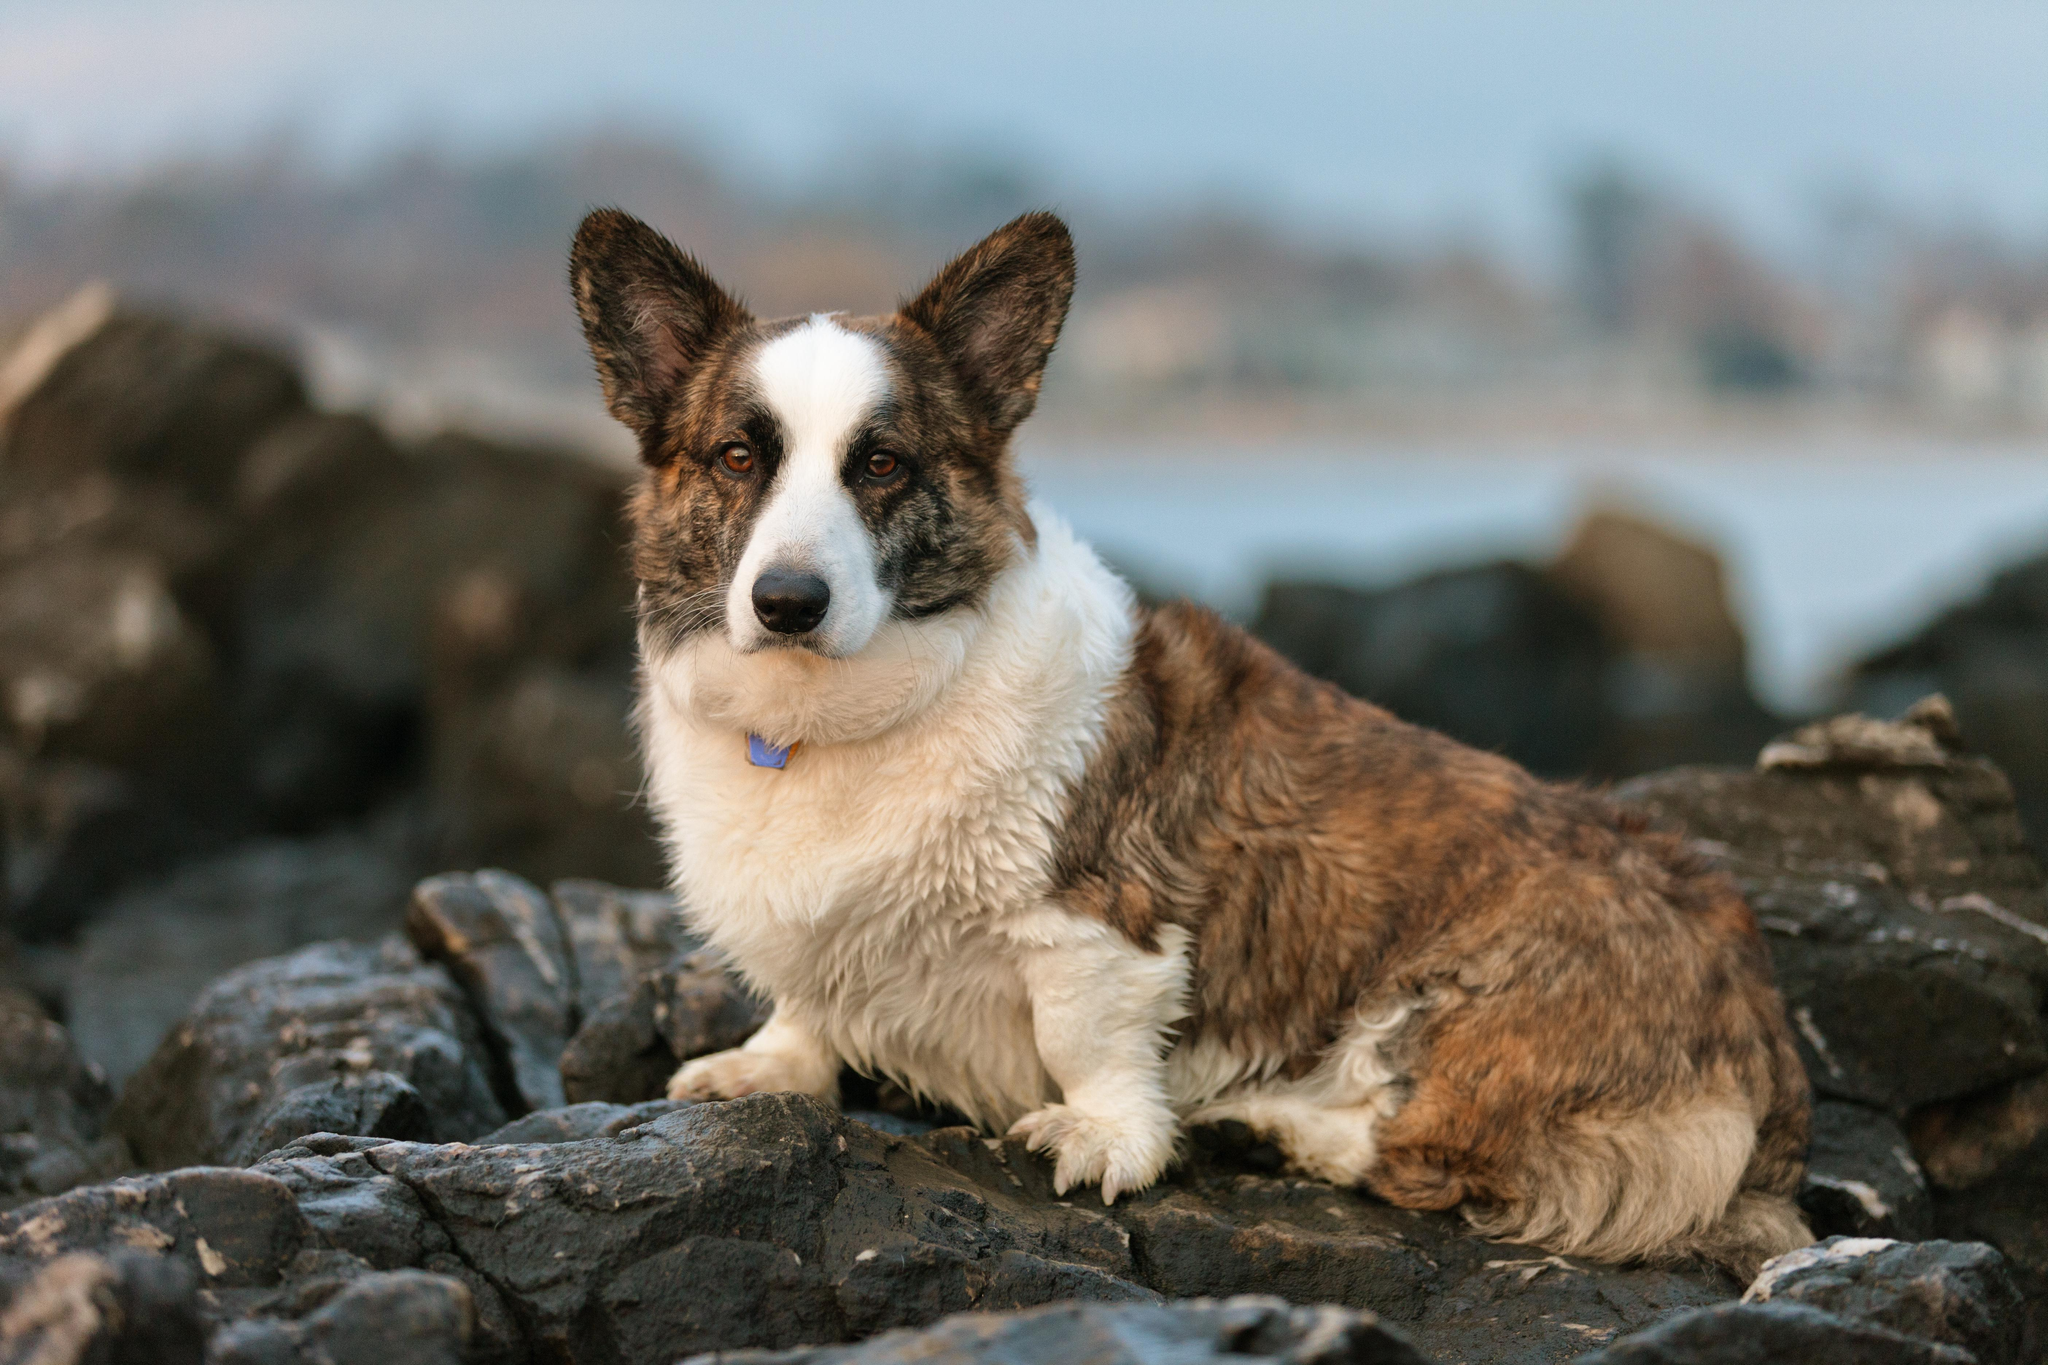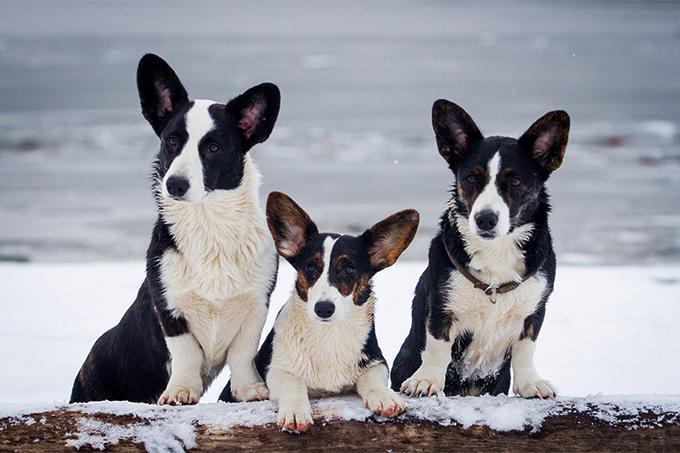The first image is the image on the left, the second image is the image on the right. Evaluate the accuracy of this statement regarding the images: "There are black and white corgis". Is it true? Answer yes or no. Yes. The first image is the image on the left, the second image is the image on the right. Assess this claim about the two images: "Two dogs with light brown ears and white muzzle is facing the camera.". Correct or not? Answer yes or no. No. 